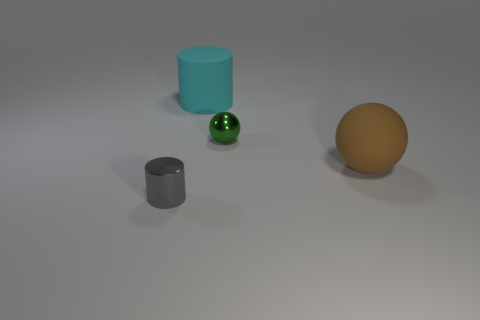Add 2 small gray metal cylinders. How many objects exist? 6 Add 2 cyan rubber objects. How many cyan rubber objects are left? 3 Add 3 spheres. How many spheres exist? 5 Subtract 0 brown blocks. How many objects are left? 4 Subtract all tiny gray objects. Subtract all gray shiny cylinders. How many objects are left? 2 